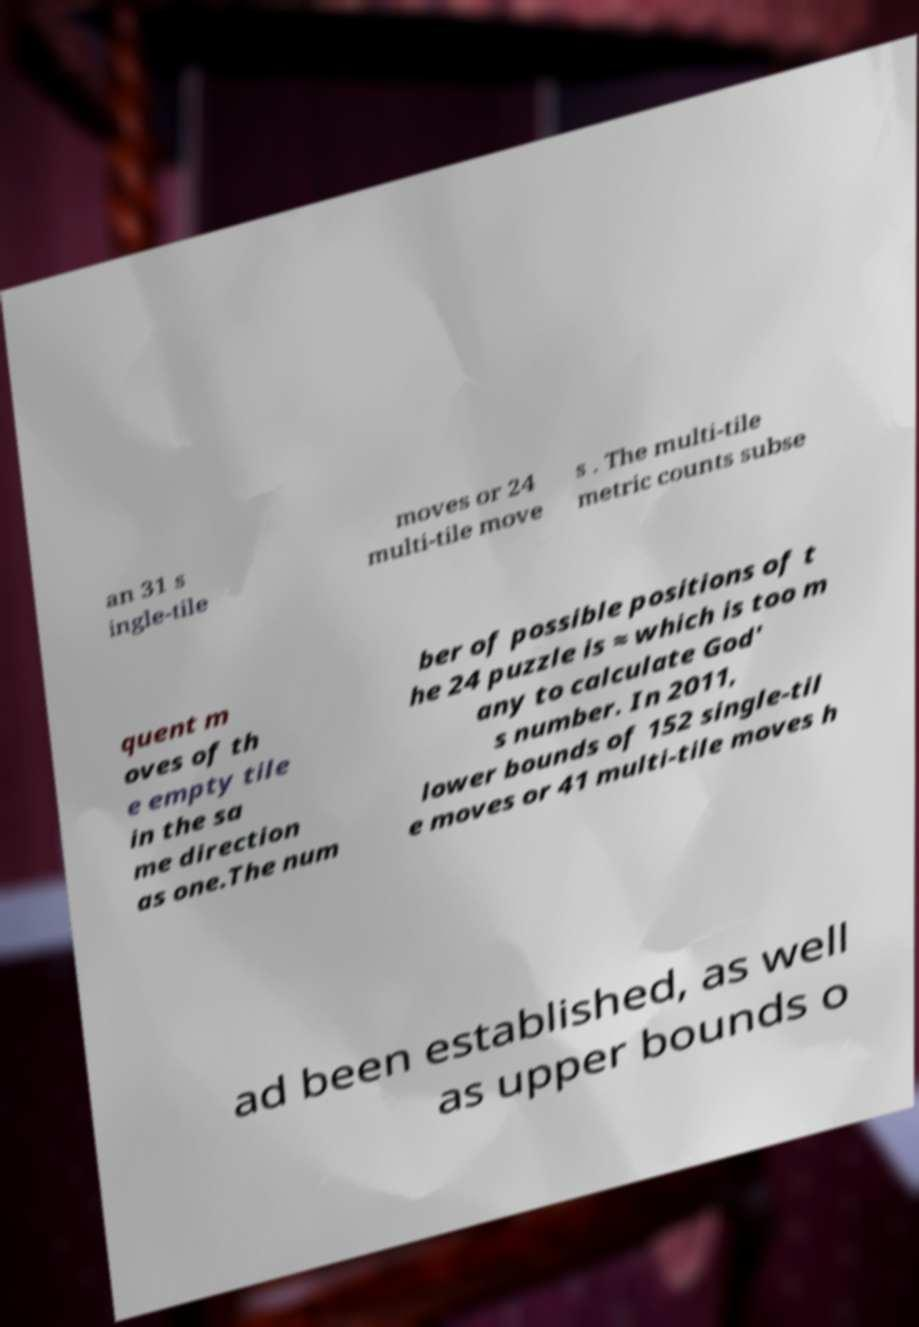There's text embedded in this image that I need extracted. Can you transcribe it verbatim? an 31 s ingle-tile moves or 24 multi-tile move s . The multi-tile metric counts subse quent m oves of th e empty tile in the sa me direction as one.The num ber of possible positions of t he 24 puzzle is ≈ which is too m any to calculate God' s number. In 2011, lower bounds of 152 single-til e moves or 41 multi-tile moves h ad been established, as well as upper bounds o 